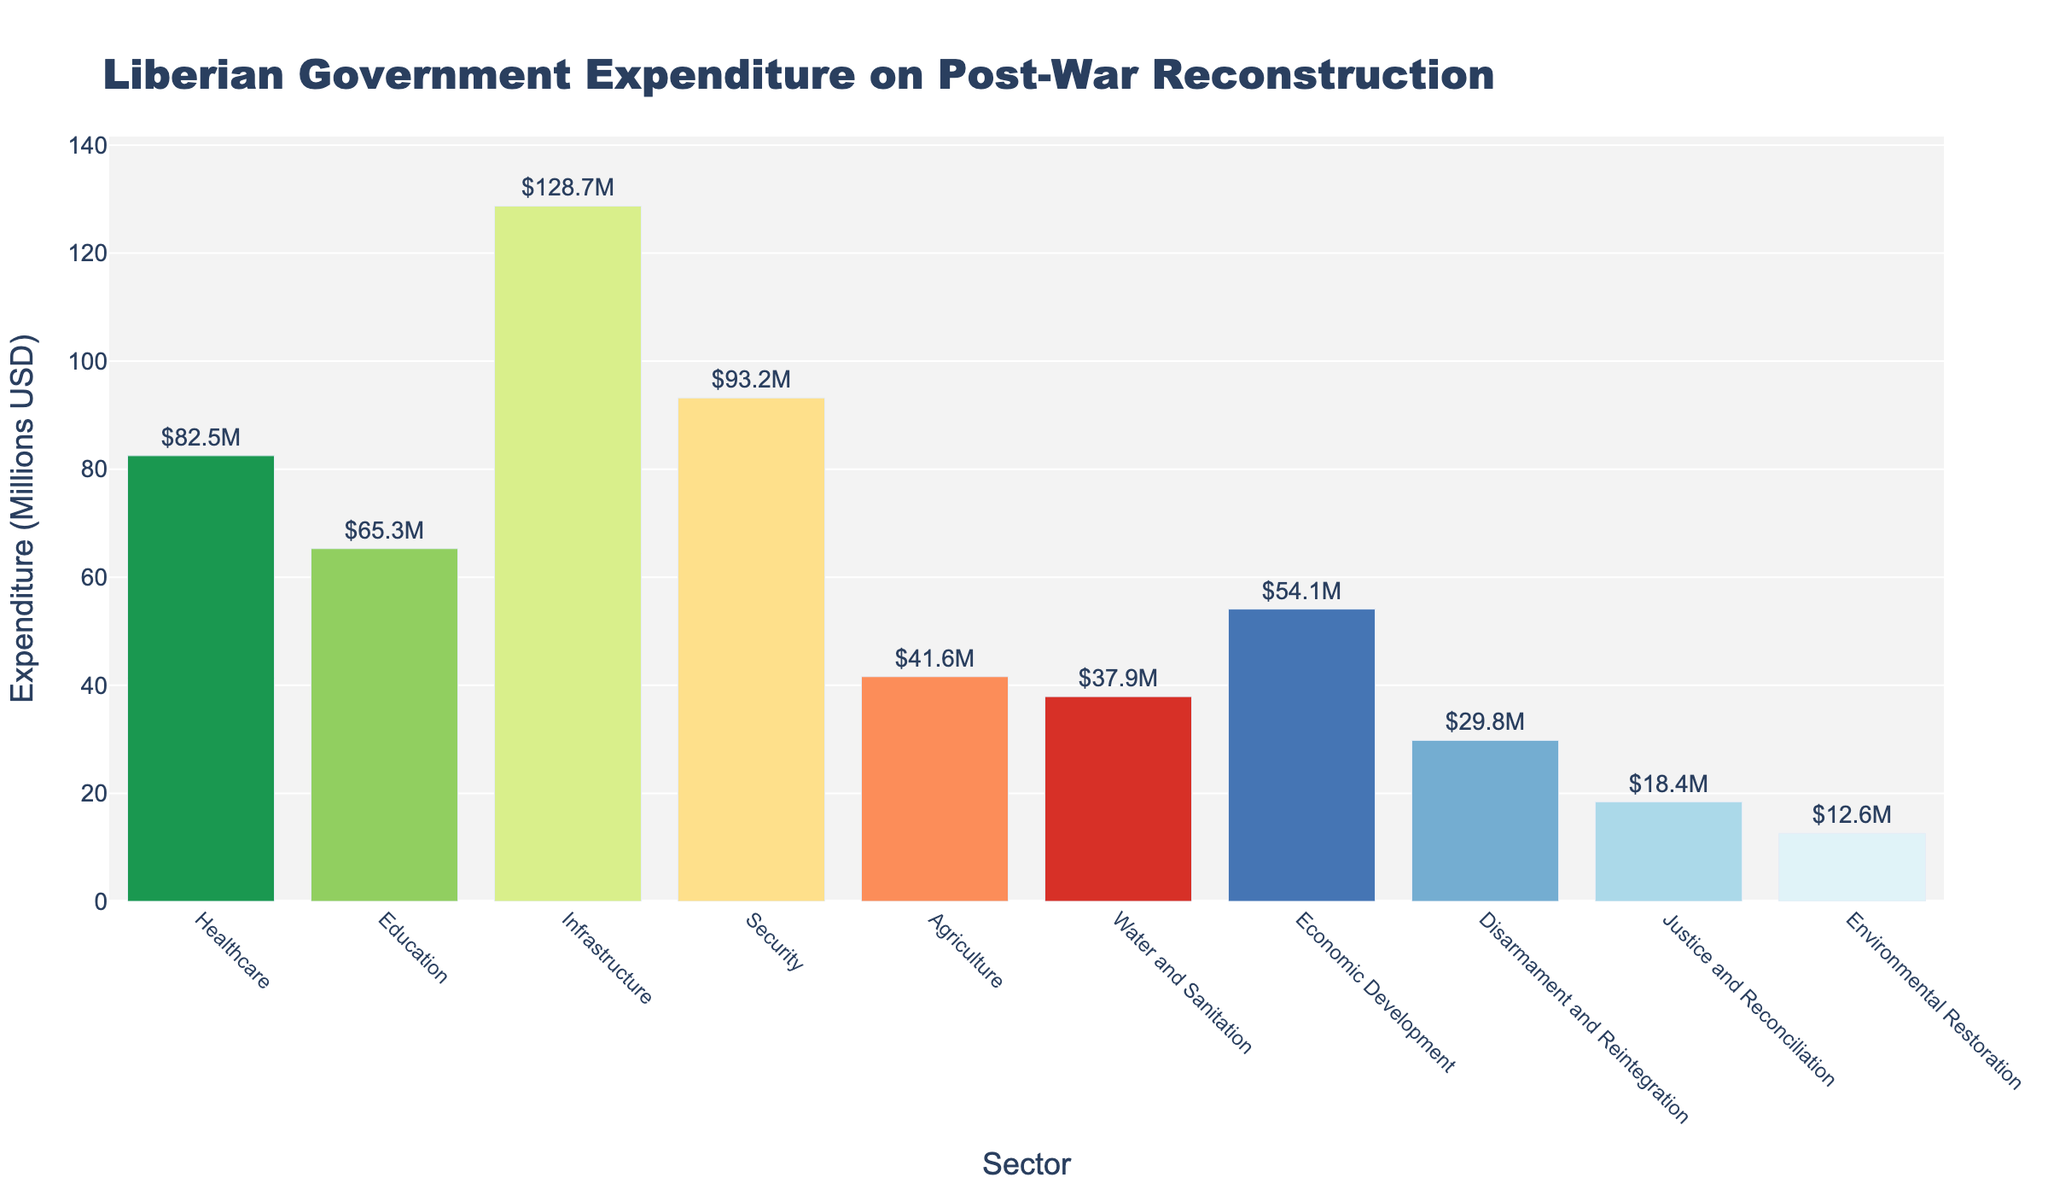What's the total expenditure on Healthcare, Education, and Infrastructure? The expenditures on Healthcare, Education, and Infrastructure are $82.5M, $65.3M, and $128.7M respectively. Adding these values gives: $82.5M + $65.3M + $128.7M = $276.5M
Answer: $276.5M Which sector receives the highest expenditure and how much is it? By looking at the heights of the bars, Infrastructure has the highest expenditure with a value of $128.7M
Answer: Infrastructure, $128.7M How much more does the Security sector receive compared to Agriculture? The expenditures for Security and Agriculture are $93.2M and $41.6M respectively. The difference is: $93.2M - $41.6M = $51.6M
Answer: $51.6M Which sectors have less than $40M in expenditure? By checking the heights of the bars for values below $40M, the sectors are Water and Sanitation ($37.9M), Disarmament and Reintegration ($29.8M), Justice and Reconciliation ($18.4M), and Environmental Restoration ($12.6M)
Answer: Water and Sanitation, Disarmament and Reintegration, Justice and Reconciliation, Environmental Restoration What's the average expenditure across all sectors? Adding all expenditures: $82.5M + $65.3M + $128.7M + $93.2M + $41.6M + $37.9M + $54.1M + $29.8M + $18.4M + $12.6M = $564.1M. There are 10 sectors, so the average expenditure is $564.1M / 10 = $56.41M
Answer: $56.41M Which sector receives the closest expenditure amount to the average expenditure? The average expenditure is $56.41M. The expenditures close to this are Education ($65.3M) and Economic Development ($54.1M). Economic Development is closer with a difference of $2.31M compared to Education’s $8.89M.
Answer: Economic Development Which sector receives the smallest expenditure and how much is it? The smallest expenditure is for Environmental Restoration with $12.6M
Answer: Environmental Restoration, $12.6M 